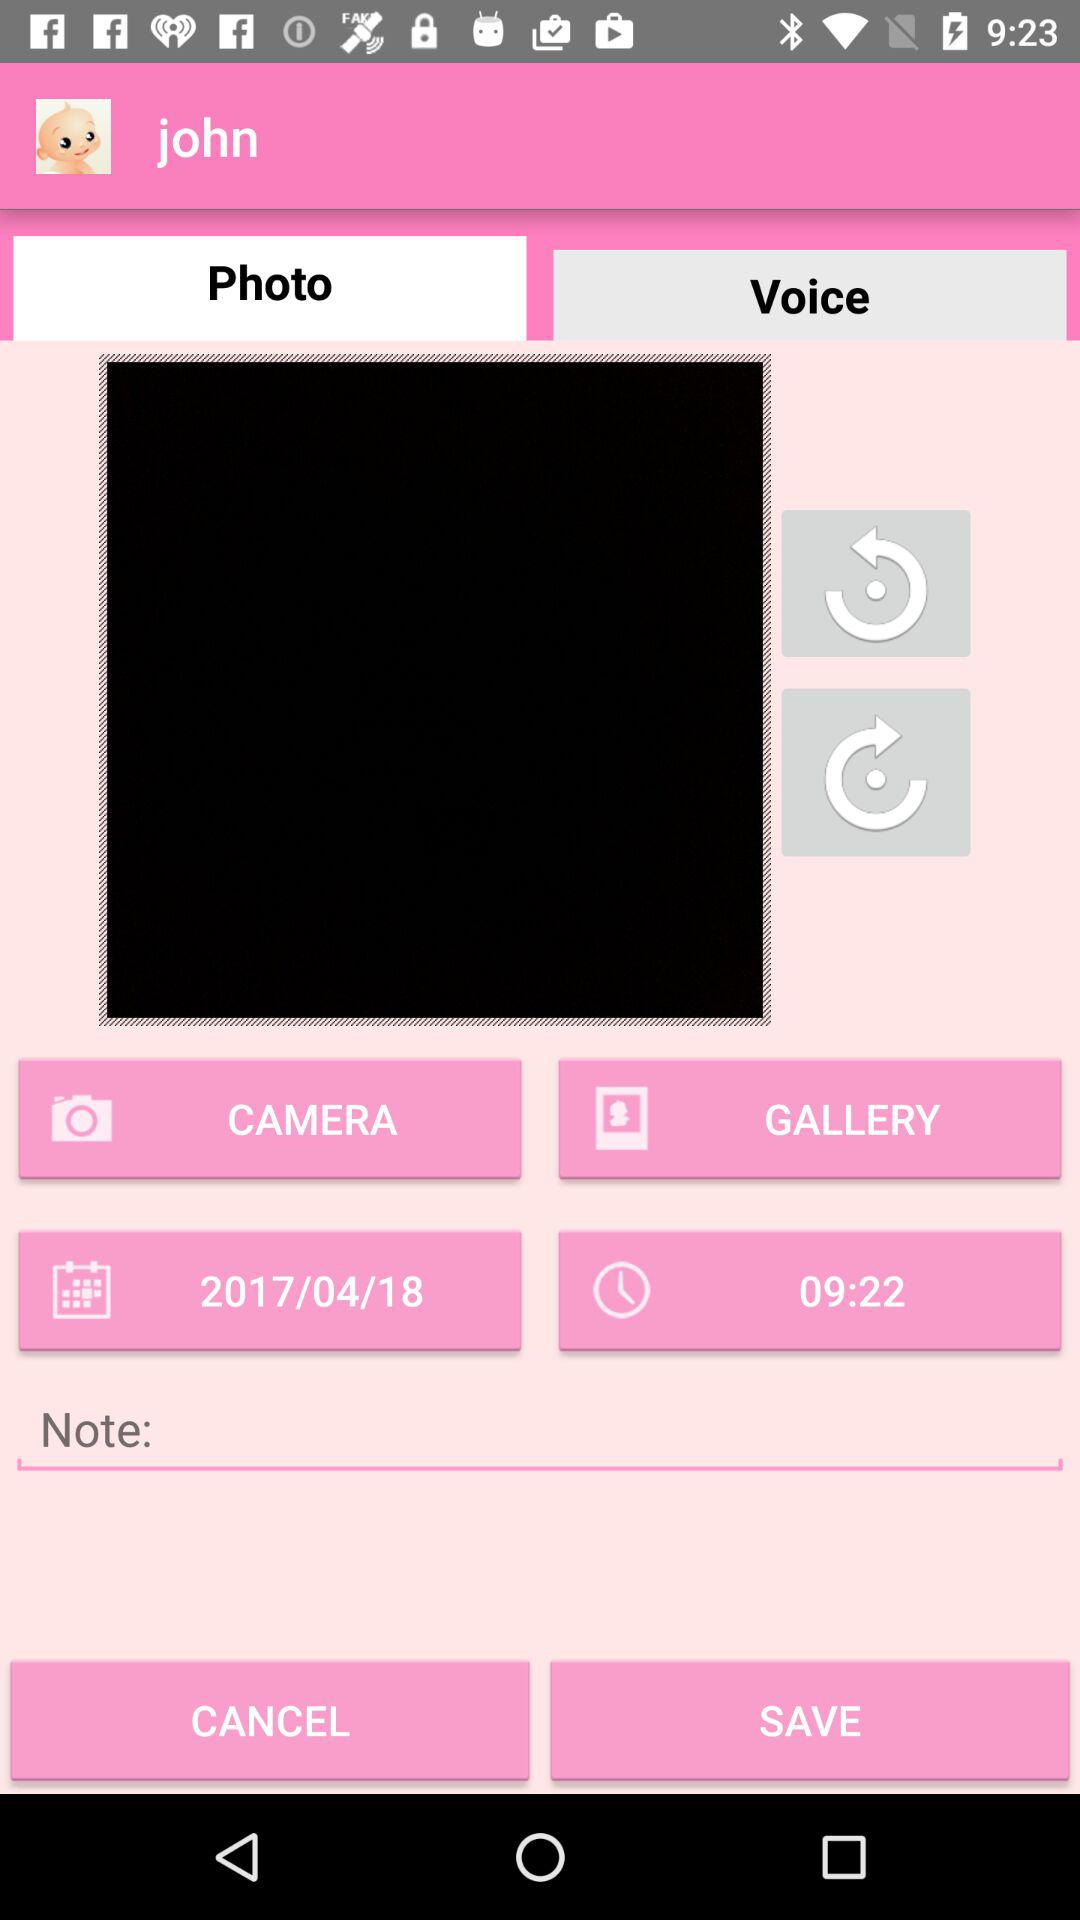What is the time? The time is 9:22. 